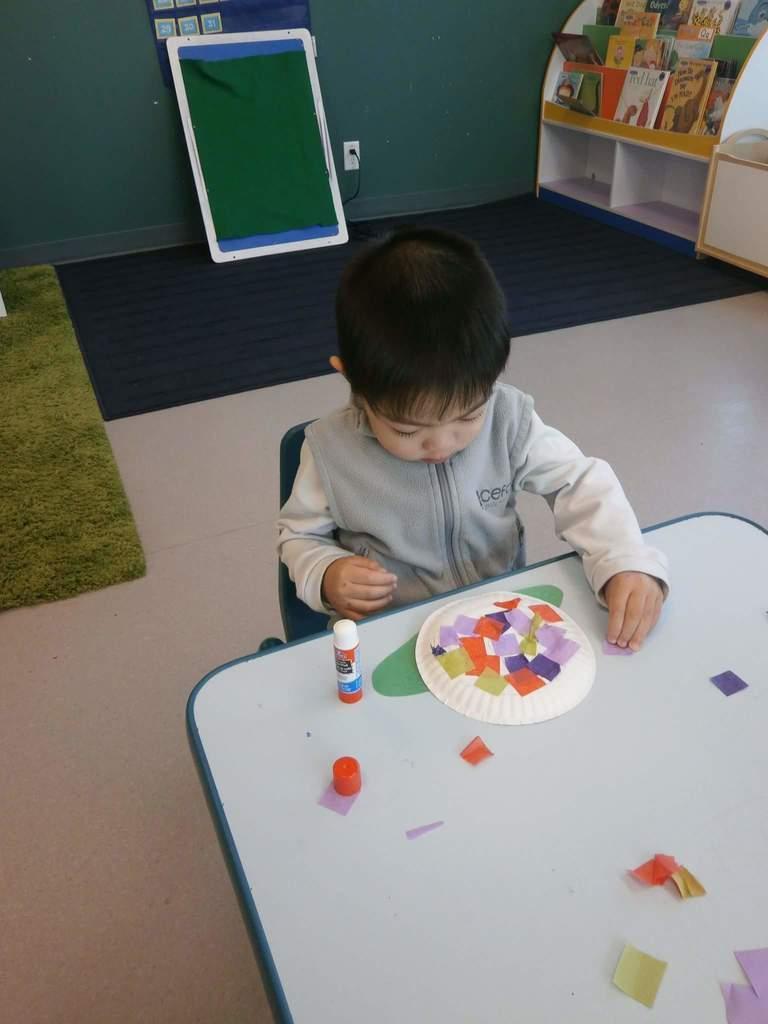How would you summarize this image in a sentence or two? In this picture we can see a kid sitting in a chair near a table & playing. 